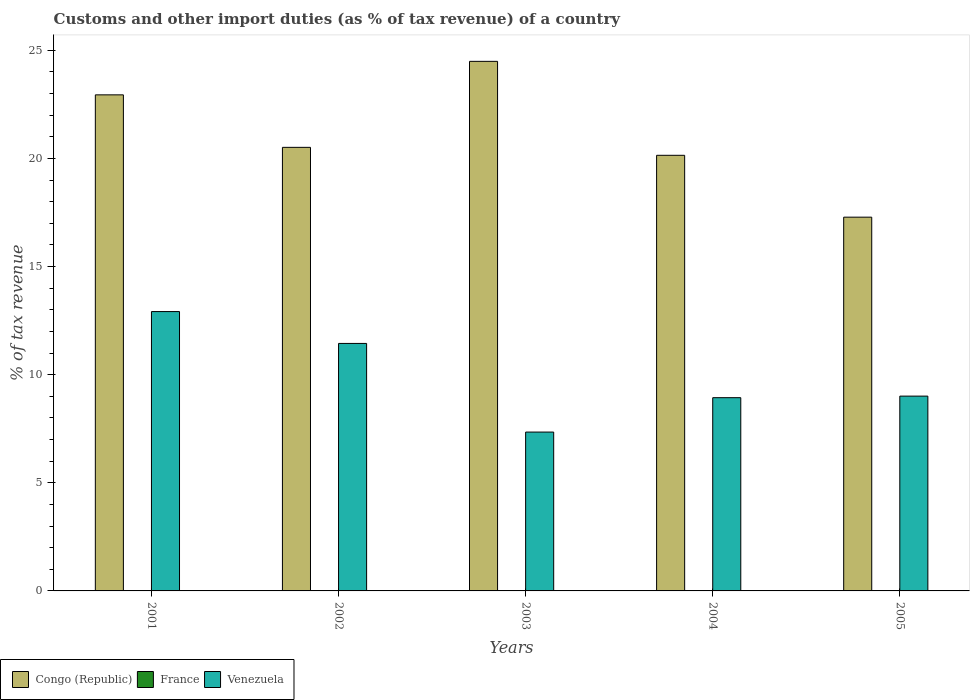Are the number of bars on each tick of the X-axis equal?
Offer a terse response. No. What is the percentage of tax revenue from customs in France in 2002?
Offer a terse response. 0. Across all years, what is the maximum percentage of tax revenue from customs in Congo (Republic)?
Provide a succinct answer. 24.49. Across all years, what is the minimum percentage of tax revenue from customs in Venezuela?
Your answer should be compact. 7.35. What is the total percentage of tax revenue from customs in Venezuela in the graph?
Offer a terse response. 49.65. What is the difference between the percentage of tax revenue from customs in France in 2001 and that in 2002?
Your answer should be compact. 0. What is the difference between the percentage of tax revenue from customs in France in 2001 and the percentage of tax revenue from customs in Congo (Republic) in 2002?
Make the answer very short. -20.51. What is the average percentage of tax revenue from customs in France per year?
Ensure brevity in your answer.  0. In the year 2005, what is the difference between the percentage of tax revenue from customs in Venezuela and percentage of tax revenue from customs in Congo (Republic)?
Make the answer very short. -8.28. What is the ratio of the percentage of tax revenue from customs in Congo (Republic) in 2002 to that in 2004?
Offer a terse response. 1.02. Is the percentage of tax revenue from customs in Venezuela in 2001 less than that in 2005?
Your answer should be very brief. No. What is the difference between the highest and the second highest percentage of tax revenue from customs in France?
Ensure brevity in your answer.  0.02. What is the difference between the highest and the lowest percentage of tax revenue from customs in Congo (Republic)?
Make the answer very short. 7.2. In how many years, is the percentage of tax revenue from customs in Venezuela greater than the average percentage of tax revenue from customs in Venezuela taken over all years?
Provide a short and direct response. 2. How many bars are there?
Offer a very short reply. 13. Are all the bars in the graph horizontal?
Make the answer very short. No. How many years are there in the graph?
Offer a very short reply. 5. What is the difference between two consecutive major ticks on the Y-axis?
Your response must be concise. 5. Does the graph contain grids?
Your answer should be compact. No. How many legend labels are there?
Provide a short and direct response. 3. How are the legend labels stacked?
Keep it short and to the point. Horizontal. What is the title of the graph?
Offer a very short reply. Customs and other import duties (as % of tax revenue) of a country. What is the label or title of the Y-axis?
Provide a succinct answer. % of tax revenue. What is the % of tax revenue of Congo (Republic) in 2001?
Your response must be concise. 22.94. What is the % of tax revenue in France in 2001?
Give a very brief answer. 0. What is the % of tax revenue in Venezuela in 2001?
Your answer should be very brief. 12.92. What is the % of tax revenue in Congo (Republic) in 2002?
Provide a short and direct response. 20.51. What is the % of tax revenue in France in 2002?
Ensure brevity in your answer.  0. What is the % of tax revenue in Venezuela in 2002?
Ensure brevity in your answer.  11.44. What is the % of tax revenue in Congo (Republic) in 2003?
Make the answer very short. 24.49. What is the % of tax revenue in Venezuela in 2003?
Provide a succinct answer. 7.35. What is the % of tax revenue in Congo (Republic) in 2004?
Keep it short and to the point. 20.14. What is the % of tax revenue of Venezuela in 2004?
Your response must be concise. 8.94. What is the % of tax revenue of Congo (Republic) in 2005?
Your answer should be very brief. 17.28. What is the % of tax revenue of France in 2005?
Your answer should be compact. 0.02. What is the % of tax revenue of Venezuela in 2005?
Your answer should be very brief. 9.01. Across all years, what is the maximum % of tax revenue of Congo (Republic)?
Keep it short and to the point. 24.49. Across all years, what is the maximum % of tax revenue of France?
Your response must be concise. 0.02. Across all years, what is the maximum % of tax revenue of Venezuela?
Offer a terse response. 12.92. Across all years, what is the minimum % of tax revenue of Congo (Republic)?
Ensure brevity in your answer.  17.28. Across all years, what is the minimum % of tax revenue of France?
Give a very brief answer. 0. Across all years, what is the minimum % of tax revenue in Venezuela?
Offer a very short reply. 7.35. What is the total % of tax revenue in Congo (Republic) in the graph?
Offer a very short reply. 105.36. What is the total % of tax revenue in France in the graph?
Offer a terse response. 0.02. What is the total % of tax revenue in Venezuela in the graph?
Offer a terse response. 49.65. What is the difference between the % of tax revenue of Congo (Republic) in 2001 and that in 2002?
Make the answer very short. 2.43. What is the difference between the % of tax revenue in France in 2001 and that in 2002?
Keep it short and to the point. 0. What is the difference between the % of tax revenue of Venezuela in 2001 and that in 2002?
Ensure brevity in your answer.  1.47. What is the difference between the % of tax revenue in Congo (Republic) in 2001 and that in 2003?
Provide a succinct answer. -1.55. What is the difference between the % of tax revenue of Venezuela in 2001 and that in 2003?
Make the answer very short. 5.57. What is the difference between the % of tax revenue of Congo (Republic) in 2001 and that in 2004?
Keep it short and to the point. 2.8. What is the difference between the % of tax revenue in Venezuela in 2001 and that in 2004?
Provide a short and direct response. 3.98. What is the difference between the % of tax revenue of Congo (Republic) in 2001 and that in 2005?
Give a very brief answer. 5.66. What is the difference between the % of tax revenue of France in 2001 and that in 2005?
Provide a succinct answer. -0.02. What is the difference between the % of tax revenue in Venezuela in 2001 and that in 2005?
Keep it short and to the point. 3.91. What is the difference between the % of tax revenue of Congo (Republic) in 2002 and that in 2003?
Make the answer very short. -3.98. What is the difference between the % of tax revenue in Venezuela in 2002 and that in 2003?
Make the answer very short. 4.1. What is the difference between the % of tax revenue in Congo (Republic) in 2002 and that in 2004?
Give a very brief answer. 0.37. What is the difference between the % of tax revenue in Venezuela in 2002 and that in 2004?
Make the answer very short. 2.51. What is the difference between the % of tax revenue in Congo (Republic) in 2002 and that in 2005?
Your answer should be compact. 3.23. What is the difference between the % of tax revenue in France in 2002 and that in 2005?
Ensure brevity in your answer.  -0.02. What is the difference between the % of tax revenue in Venezuela in 2002 and that in 2005?
Provide a succinct answer. 2.44. What is the difference between the % of tax revenue in Congo (Republic) in 2003 and that in 2004?
Offer a very short reply. 4.34. What is the difference between the % of tax revenue of Venezuela in 2003 and that in 2004?
Keep it short and to the point. -1.59. What is the difference between the % of tax revenue in Congo (Republic) in 2003 and that in 2005?
Your answer should be very brief. 7.2. What is the difference between the % of tax revenue in Venezuela in 2003 and that in 2005?
Provide a succinct answer. -1.66. What is the difference between the % of tax revenue in Congo (Republic) in 2004 and that in 2005?
Your answer should be compact. 2.86. What is the difference between the % of tax revenue of Venezuela in 2004 and that in 2005?
Offer a terse response. -0.07. What is the difference between the % of tax revenue of Congo (Republic) in 2001 and the % of tax revenue of France in 2002?
Provide a succinct answer. 22.94. What is the difference between the % of tax revenue in Congo (Republic) in 2001 and the % of tax revenue in Venezuela in 2002?
Your answer should be very brief. 11.49. What is the difference between the % of tax revenue of France in 2001 and the % of tax revenue of Venezuela in 2002?
Keep it short and to the point. -11.44. What is the difference between the % of tax revenue in Congo (Republic) in 2001 and the % of tax revenue in Venezuela in 2003?
Your response must be concise. 15.59. What is the difference between the % of tax revenue of France in 2001 and the % of tax revenue of Venezuela in 2003?
Give a very brief answer. -7.34. What is the difference between the % of tax revenue of Congo (Republic) in 2001 and the % of tax revenue of Venezuela in 2004?
Ensure brevity in your answer.  14. What is the difference between the % of tax revenue in France in 2001 and the % of tax revenue in Venezuela in 2004?
Give a very brief answer. -8.93. What is the difference between the % of tax revenue in Congo (Republic) in 2001 and the % of tax revenue in France in 2005?
Keep it short and to the point. 22.92. What is the difference between the % of tax revenue of Congo (Republic) in 2001 and the % of tax revenue of Venezuela in 2005?
Keep it short and to the point. 13.93. What is the difference between the % of tax revenue in France in 2001 and the % of tax revenue in Venezuela in 2005?
Your answer should be very brief. -9.01. What is the difference between the % of tax revenue in Congo (Republic) in 2002 and the % of tax revenue in Venezuela in 2003?
Keep it short and to the point. 13.17. What is the difference between the % of tax revenue of France in 2002 and the % of tax revenue of Venezuela in 2003?
Keep it short and to the point. -7.34. What is the difference between the % of tax revenue in Congo (Republic) in 2002 and the % of tax revenue in Venezuela in 2004?
Keep it short and to the point. 11.58. What is the difference between the % of tax revenue in France in 2002 and the % of tax revenue in Venezuela in 2004?
Give a very brief answer. -8.93. What is the difference between the % of tax revenue in Congo (Republic) in 2002 and the % of tax revenue in France in 2005?
Keep it short and to the point. 20.49. What is the difference between the % of tax revenue of Congo (Republic) in 2002 and the % of tax revenue of Venezuela in 2005?
Keep it short and to the point. 11.5. What is the difference between the % of tax revenue in France in 2002 and the % of tax revenue in Venezuela in 2005?
Make the answer very short. -9.01. What is the difference between the % of tax revenue of Congo (Republic) in 2003 and the % of tax revenue of Venezuela in 2004?
Your answer should be very brief. 15.55. What is the difference between the % of tax revenue of Congo (Republic) in 2003 and the % of tax revenue of France in 2005?
Offer a terse response. 24.47. What is the difference between the % of tax revenue of Congo (Republic) in 2003 and the % of tax revenue of Venezuela in 2005?
Give a very brief answer. 15.48. What is the difference between the % of tax revenue of Congo (Republic) in 2004 and the % of tax revenue of France in 2005?
Your response must be concise. 20.12. What is the difference between the % of tax revenue in Congo (Republic) in 2004 and the % of tax revenue in Venezuela in 2005?
Keep it short and to the point. 11.14. What is the average % of tax revenue in Congo (Republic) per year?
Provide a short and direct response. 21.07. What is the average % of tax revenue in France per year?
Your answer should be very brief. 0. What is the average % of tax revenue of Venezuela per year?
Offer a terse response. 9.93. In the year 2001, what is the difference between the % of tax revenue of Congo (Republic) and % of tax revenue of France?
Provide a short and direct response. 22.94. In the year 2001, what is the difference between the % of tax revenue of Congo (Republic) and % of tax revenue of Venezuela?
Your answer should be very brief. 10.02. In the year 2001, what is the difference between the % of tax revenue in France and % of tax revenue in Venezuela?
Provide a short and direct response. -12.92. In the year 2002, what is the difference between the % of tax revenue of Congo (Republic) and % of tax revenue of France?
Your answer should be very brief. 20.51. In the year 2002, what is the difference between the % of tax revenue of Congo (Republic) and % of tax revenue of Venezuela?
Give a very brief answer. 9.07. In the year 2002, what is the difference between the % of tax revenue of France and % of tax revenue of Venezuela?
Provide a short and direct response. -11.44. In the year 2003, what is the difference between the % of tax revenue of Congo (Republic) and % of tax revenue of Venezuela?
Ensure brevity in your answer.  17.14. In the year 2004, what is the difference between the % of tax revenue of Congo (Republic) and % of tax revenue of Venezuela?
Keep it short and to the point. 11.21. In the year 2005, what is the difference between the % of tax revenue of Congo (Republic) and % of tax revenue of France?
Offer a very short reply. 17.26. In the year 2005, what is the difference between the % of tax revenue in Congo (Republic) and % of tax revenue in Venezuela?
Ensure brevity in your answer.  8.28. In the year 2005, what is the difference between the % of tax revenue in France and % of tax revenue in Venezuela?
Offer a very short reply. -8.99. What is the ratio of the % of tax revenue of Congo (Republic) in 2001 to that in 2002?
Provide a succinct answer. 1.12. What is the ratio of the % of tax revenue of France in 2001 to that in 2002?
Make the answer very short. 1.41. What is the ratio of the % of tax revenue in Venezuela in 2001 to that in 2002?
Make the answer very short. 1.13. What is the ratio of the % of tax revenue of Congo (Republic) in 2001 to that in 2003?
Keep it short and to the point. 0.94. What is the ratio of the % of tax revenue of Venezuela in 2001 to that in 2003?
Offer a very short reply. 1.76. What is the ratio of the % of tax revenue in Congo (Republic) in 2001 to that in 2004?
Your response must be concise. 1.14. What is the ratio of the % of tax revenue of Venezuela in 2001 to that in 2004?
Make the answer very short. 1.45. What is the ratio of the % of tax revenue in Congo (Republic) in 2001 to that in 2005?
Your response must be concise. 1.33. What is the ratio of the % of tax revenue in France in 2001 to that in 2005?
Make the answer very short. 0.11. What is the ratio of the % of tax revenue in Venezuela in 2001 to that in 2005?
Offer a very short reply. 1.43. What is the ratio of the % of tax revenue of Congo (Republic) in 2002 to that in 2003?
Give a very brief answer. 0.84. What is the ratio of the % of tax revenue of Venezuela in 2002 to that in 2003?
Provide a short and direct response. 1.56. What is the ratio of the % of tax revenue of Congo (Republic) in 2002 to that in 2004?
Offer a terse response. 1.02. What is the ratio of the % of tax revenue of Venezuela in 2002 to that in 2004?
Keep it short and to the point. 1.28. What is the ratio of the % of tax revenue in Congo (Republic) in 2002 to that in 2005?
Give a very brief answer. 1.19. What is the ratio of the % of tax revenue of France in 2002 to that in 2005?
Your response must be concise. 0.08. What is the ratio of the % of tax revenue in Venezuela in 2002 to that in 2005?
Provide a succinct answer. 1.27. What is the ratio of the % of tax revenue in Congo (Republic) in 2003 to that in 2004?
Your answer should be very brief. 1.22. What is the ratio of the % of tax revenue of Venezuela in 2003 to that in 2004?
Ensure brevity in your answer.  0.82. What is the ratio of the % of tax revenue in Congo (Republic) in 2003 to that in 2005?
Offer a very short reply. 1.42. What is the ratio of the % of tax revenue of Venezuela in 2003 to that in 2005?
Provide a short and direct response. 0.82. What is the ratio of the % of tax revenue of Congo (Republic) in 2004 to that in 2005?
Your response must be concise. 1.17. What is the difference between the highest and the second highest % of tax revenue of Congo (Republic)?
Provide a short and direct response. 1.55. What is the difference between the highest and the second highest % of tax revenue of France?
Provide a short and direct response. 0.02. What is the difference between the highest and the second highest % of tax revenue of Venezuela?
Give a very brief answer. 1.47. What is the difference between the highest and the lowest % of tax revenue of Congo (Republic)?
Provide a succinct answer. 7.2. What is the difference between the highest and the lowest % of tax revenue of France?
Ensure brevity in your answer.  0.02. What is the difference between the highest and the lowest % of tax revenue in Venezuela?
Your answer should be very brief. 5.57. 